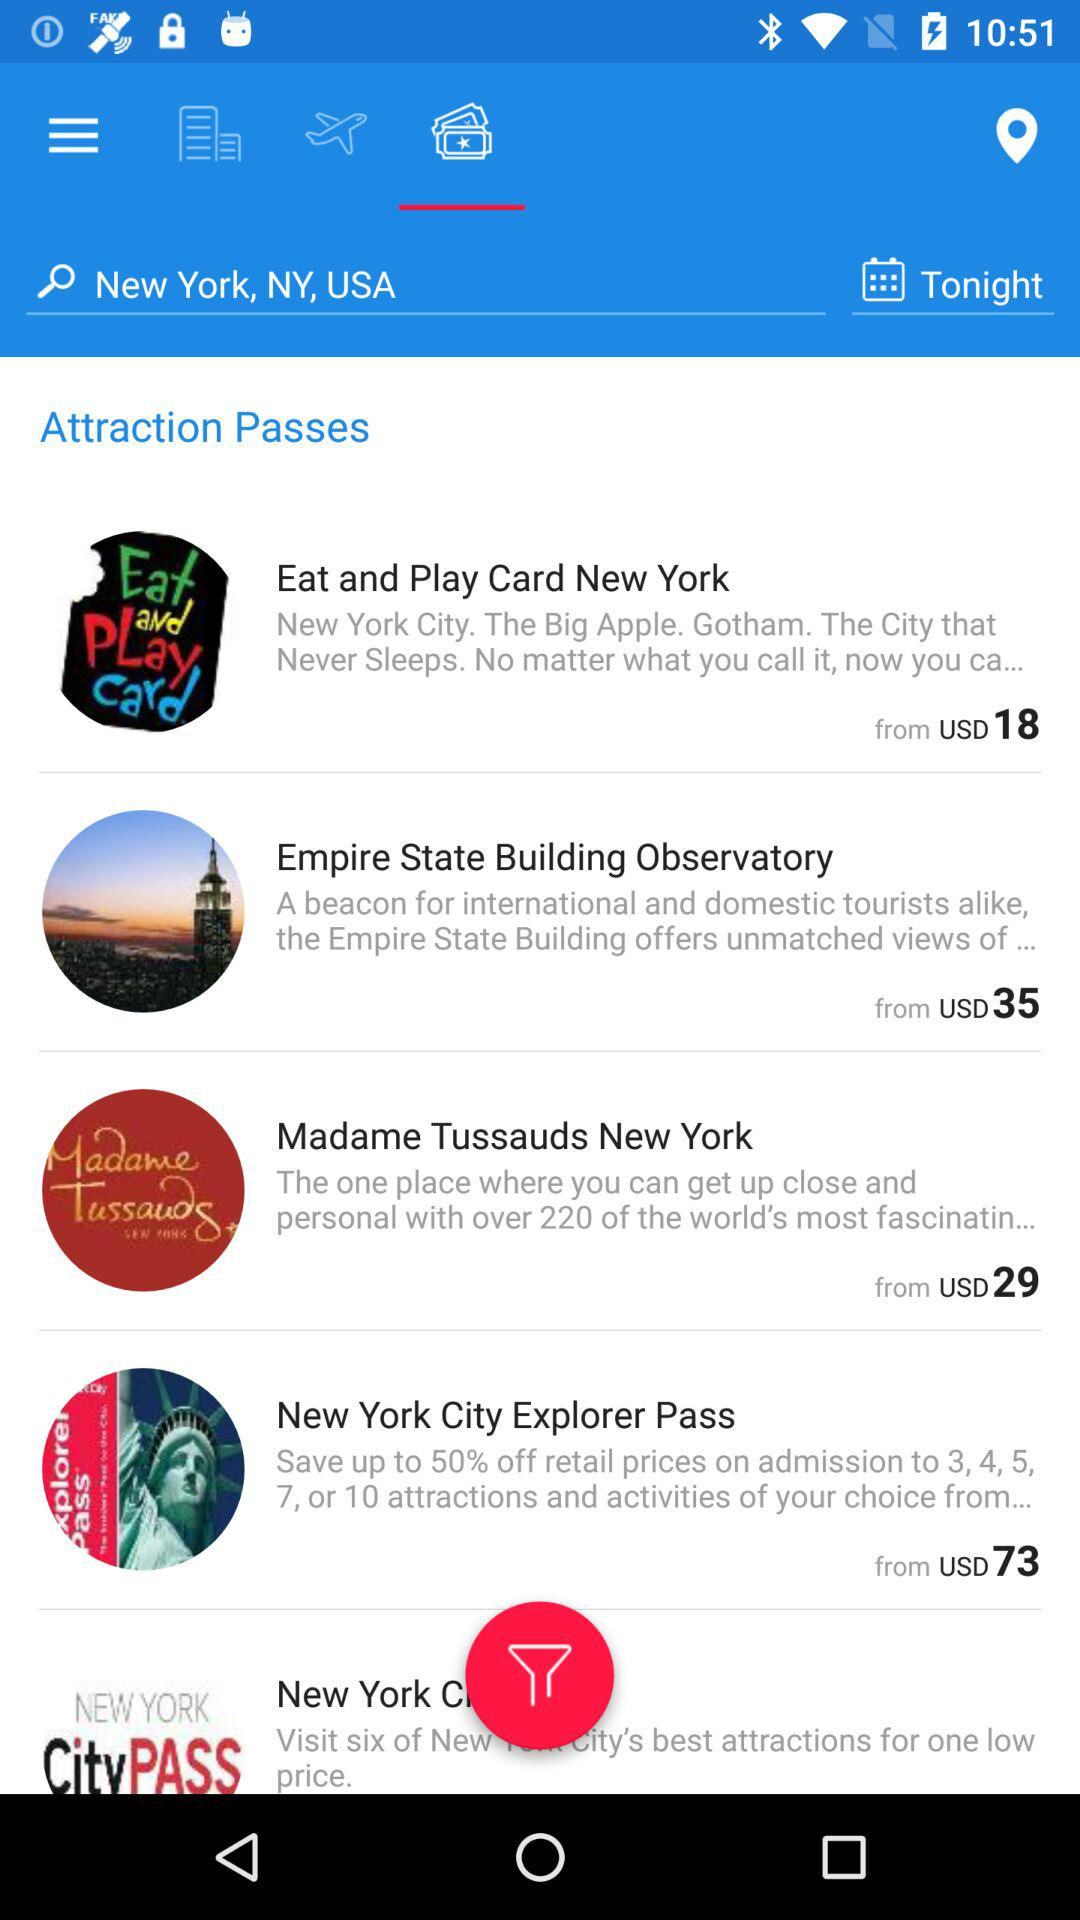What is the entered location? The entered location is New York, NY, USA. 